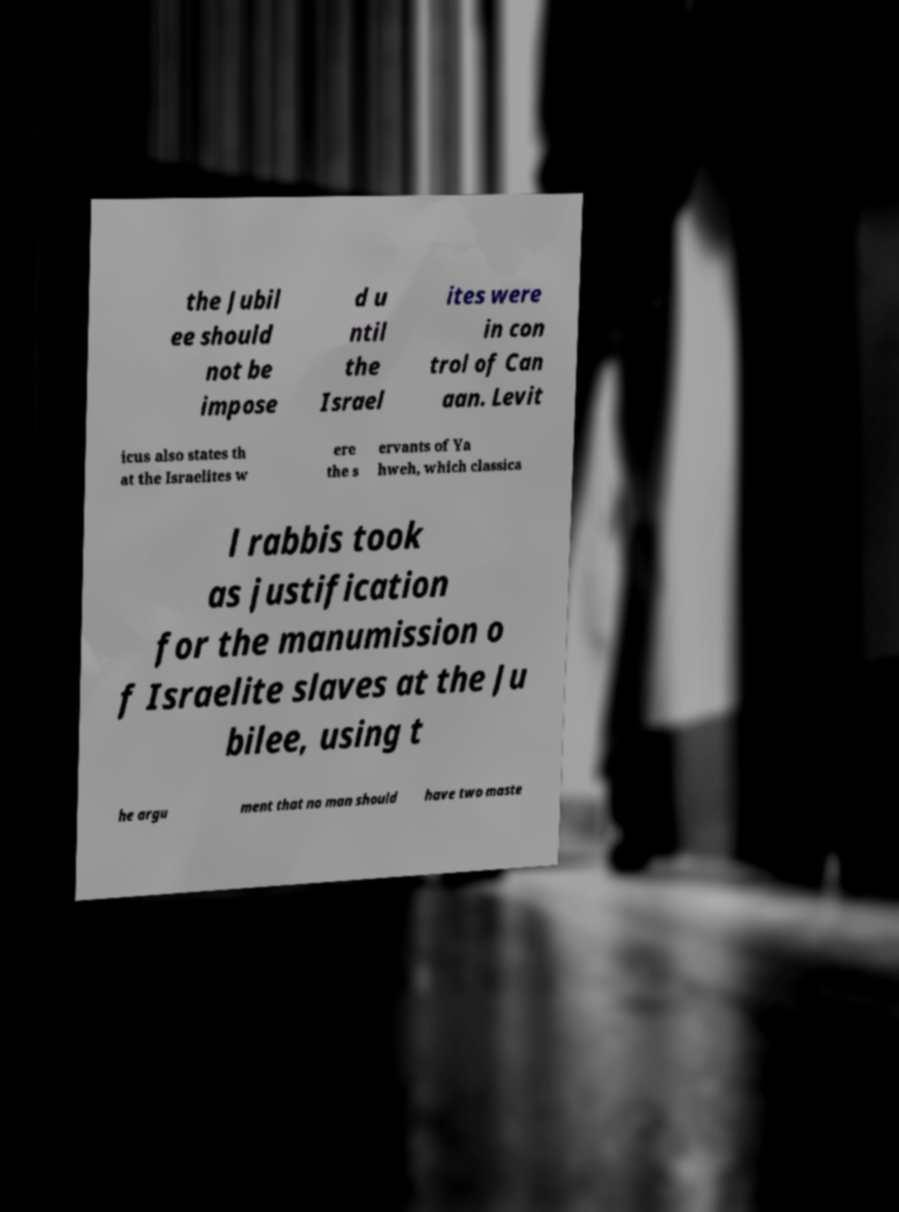Could you assist in decoding the text presented in this image and type it out clearly? the Jubil ee should not be impose d u ntil the Israel ites were in con trol of Can aan. Levit icus also states th at the Israelites w ere the s ervants of Ya hweh, which classica l rabbis took as justification for the manumission o f Israelite slaves at the Ju bilee, using t he argu ment that no man should have two maste 